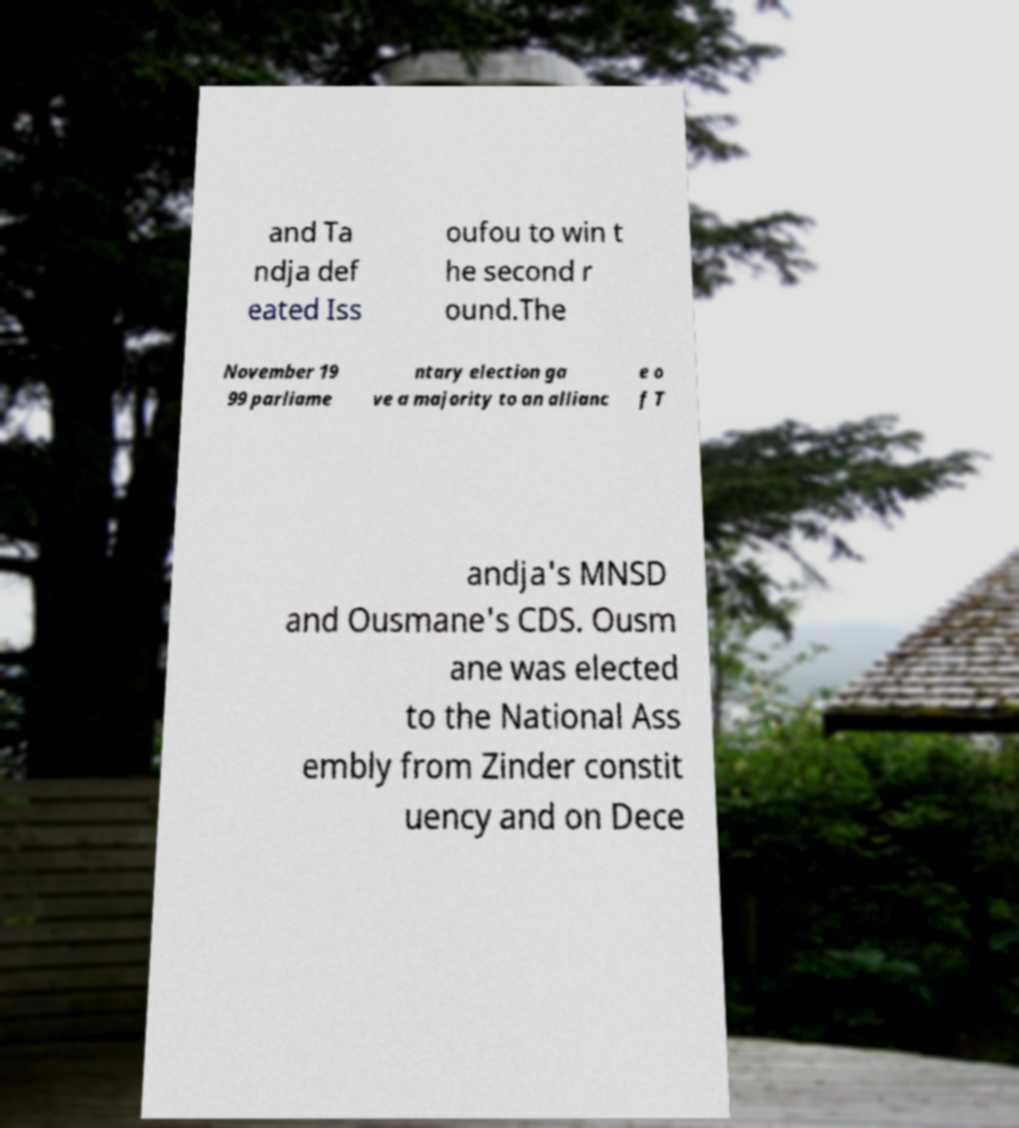Could you assist in decoding the text presented in this image and type it out clearly? and Ta ndja def eated Iss oufou to win t he second r ound.The November 19 99 parliame ntary election ga ve a majority to an allianc e o f T andja's MNSD and Ousmane's CDS. Ousm ane was elected to the National Ass embly from Zinder constit uency and on Dece 